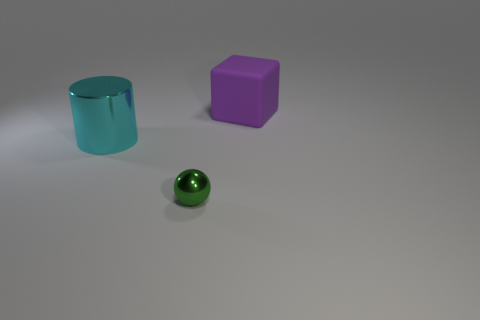Add 1 brown metal things. How many objects exist? 4 Subtract all big metallic blocks. Subtract all large purple matte things. How many objects are left? 2 Add 2 big blocks. How many big blocks are left? 3 Add 2 big purple rubber cubes. How many big purple rubber cubes exist? 3 Subtract 0 cyan cubes. How many objects are left? 3 Subtract all balls. How many objects are left? 2 Subtract all yellow cylinders. How many brown spheres are left? 0 